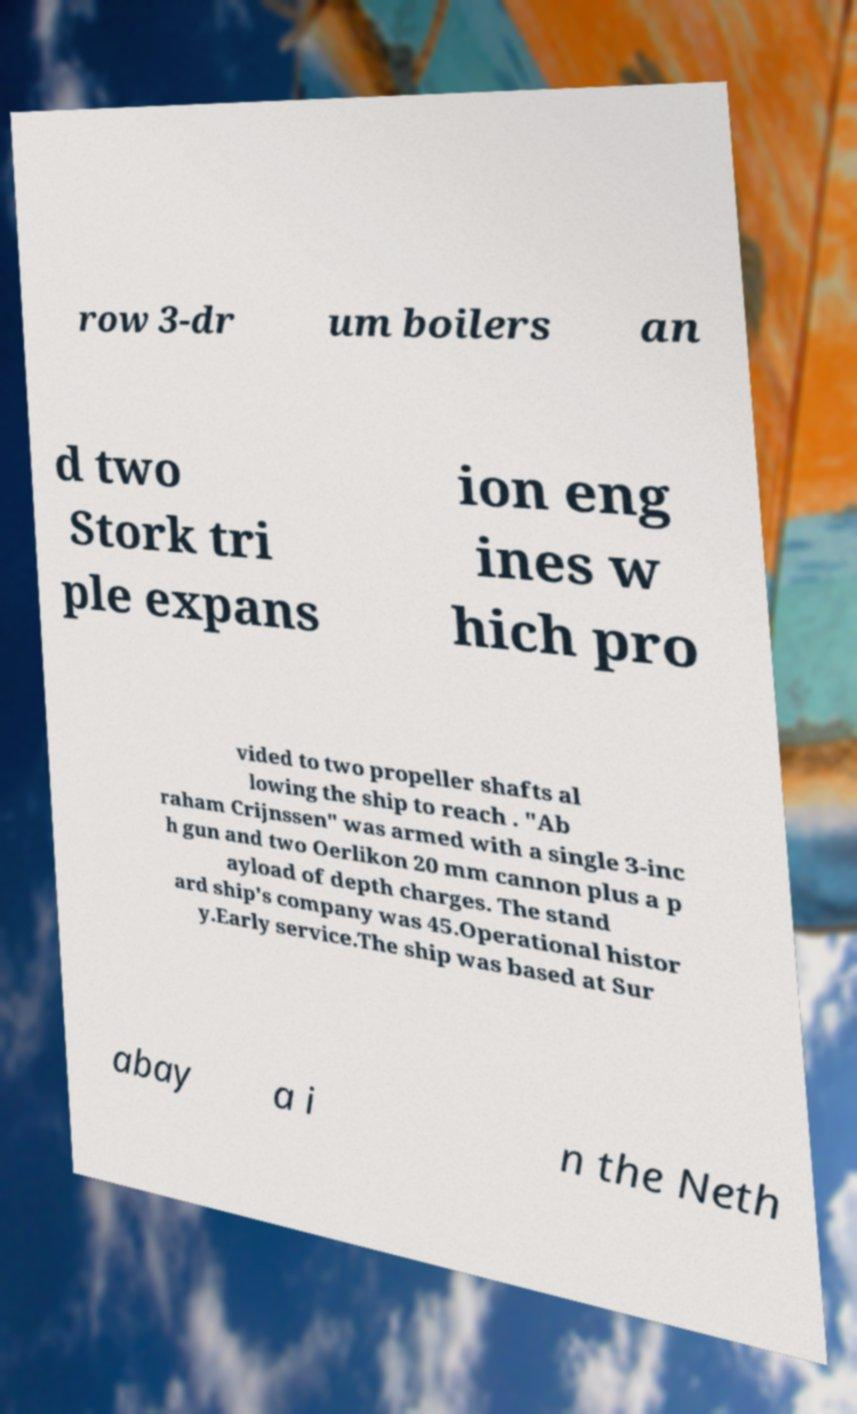Can you accurately transcribe the text from the provided image for me? row 3-dr um boilers an d two Stork tri ple expans ion eng ines w hich pro vided to two propeller shafts al lowing the ship to reach . "Ab raham Crijnssen" was armed with a single 3-inc h gun and two Oerlikon 20 mm cannon plus a p ayload of depth charges. The stand ard ship's company was 45.Operational histor y.Early service.The ship was based at Sur abay a i n the Neth 